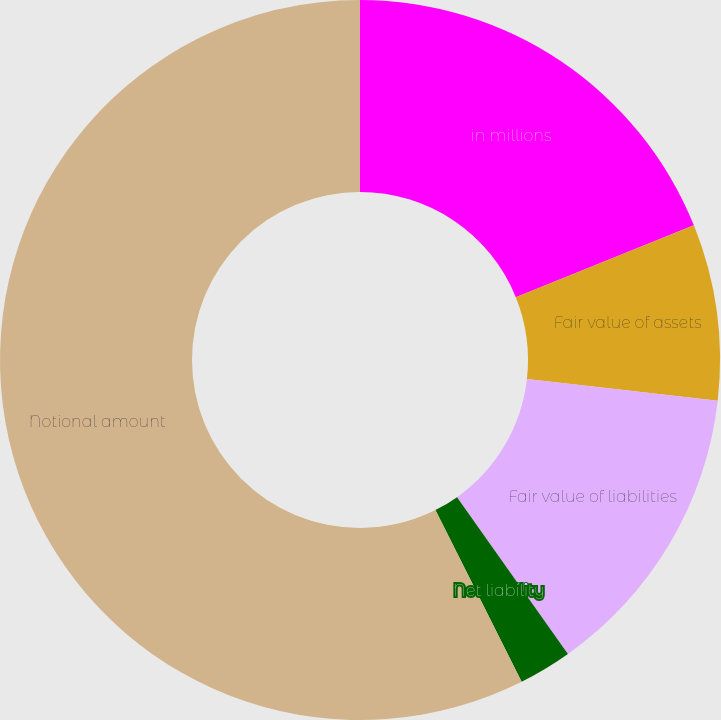Convert chart to OTSL. <chart><loc_0><loc_0><loc_500><loc_500><pie_chart><fcel>in millions<fcel>Fair value of assets<fcel>Fair value of liabilities<fcel>Net liability<fcel>Notional amount<nl><fcel>18.9%<fcel>7.9%<fcel>13.4%<fcel>2.39%<fcel>57.41%<nl></chart> 